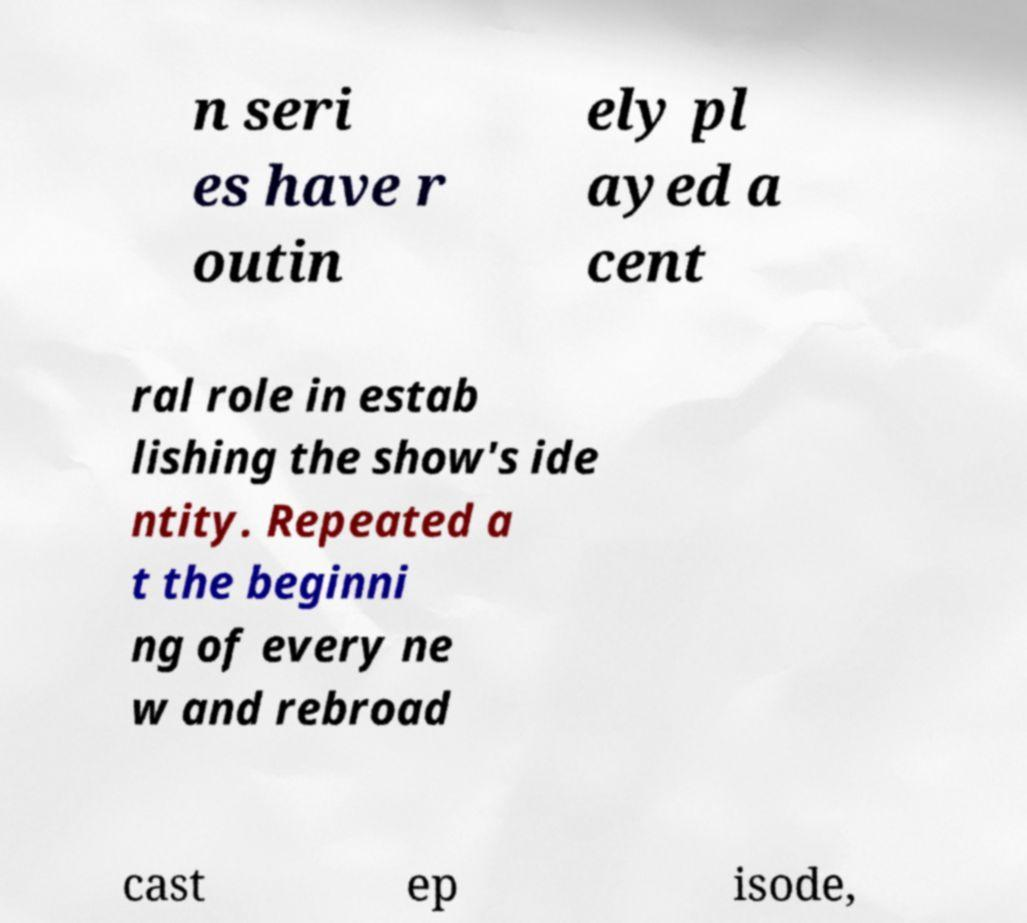I need the written content from this picture converted into text. Can you do that? n seri es have r outin ely pl ayed a cent ral role in estab lishing the show's ide ntity. Repeated a t the beginni ng of every ne w and rebroad cast ep isode, 